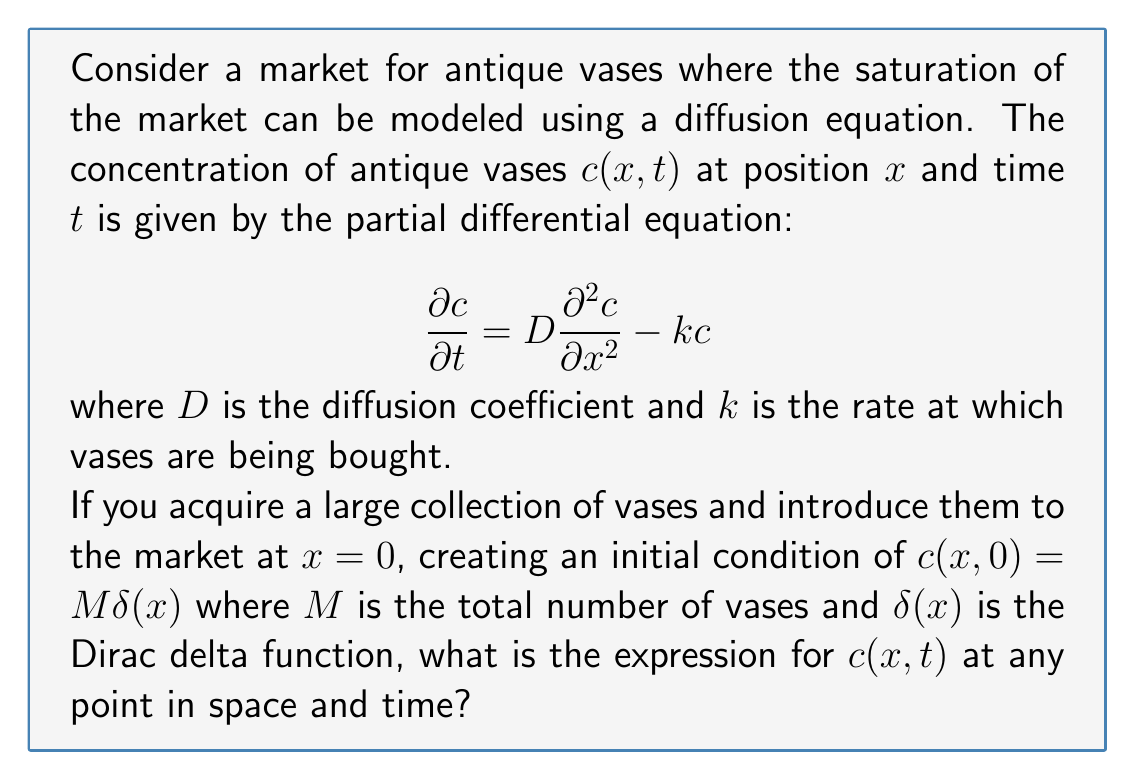Give your solution to this math problem. To solve this problem, we need to use the method of Fourier transforms. Let's approach this step-by-step:

1) First, we apply the Fourier transform to both sides of the equation with respect to $x$:

   $$\frac{\partial \tilde{c}}{\partial t} = -D\omega^2\tilde{c} - k\tilde{c}$$

   where $\tilde{c}(\omega,t)$ is the Fourier transform of $c(x,t)$.

2) This is now an ordinary differential equation in $t$:

   $$\frac{\partial \tilde{c}}{\partial t} = -(D\omega^2 + k)\tilde{c}$$

3) The solution to this ODE is:

   $$\tilde{c}(\omega,t) = \tilde{c}(\omega,0)e^{-(D\omega^2 + k)t}$$

4) The initial condition in Fourier space is:

   $$\tilde{c}(\omega,0) = M$$

   because the Fourier transform of $\delta(x)$ is 1.

5) Therefore:

   $$\tilde{c}(\omega,t) = Me^{-(D\omega^2 + k)t}$$

6) To get back to real space, we need to take the inverse Fourier transform:

   $$c(x,t) = \frac{1}{2\pi}\int_{-\infty}^{\infty} Me^{-(D\omega^2 + k)t}e^{i\omega x}d\omega$$

7) This integral can be evaluated using the method of completing the square:

   $$c(x,t) = \frac{M}{2\pi}\int_{-\infty}^{\infty} e^{-(D\omega^2 + k)t + i\omega x}d\omega$$
   
   $$= \frac{M}{2\pi}e^{-kt}\int_{-\infty}^{\infty} e^{-D\omega^2t + i\omega x}d\omega$$
   
   $$= \frac{M}{2\pi}e^{-kt}\sqrt{\frac{\pi}{Dt}}e^{-\frac{x^2}{4Dt}}$$

8) Simplifying:

   $$c(x,t) = \frac{M}{\sqrt{4\pi Dt}}e^{-kt}e^{-\frac{x^2}{4Dt}}$$

This is the final expression for the concentration of antique vases at any point in space and time.
Answer: $$c(x,t) = \frac{M}{\sqrt{4\pi Dt}}e^{-kt}e^{-\frac{x^2}{4Dt}}$$ 